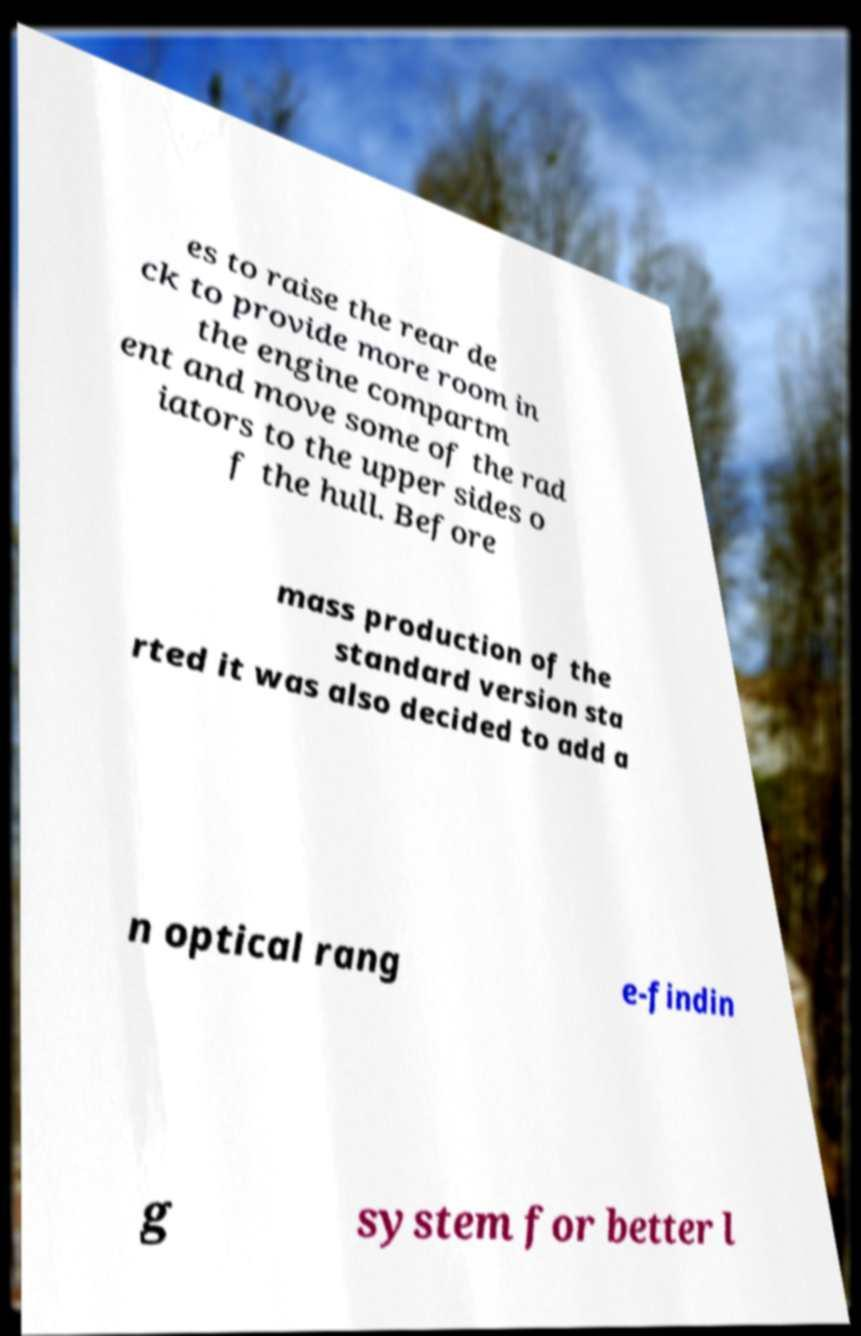Can you read and provide the text displayed in the image?This photo seems to have some interesting text. Can you extract and type it out for me? es to raise the rear de ck to provide more room in the engine compartm ent and move some of the rad iators to the upper sides o f the hull. Before mass production of the standard version sta rted it was also decided to add a n optical rang e-findin g system for better l 